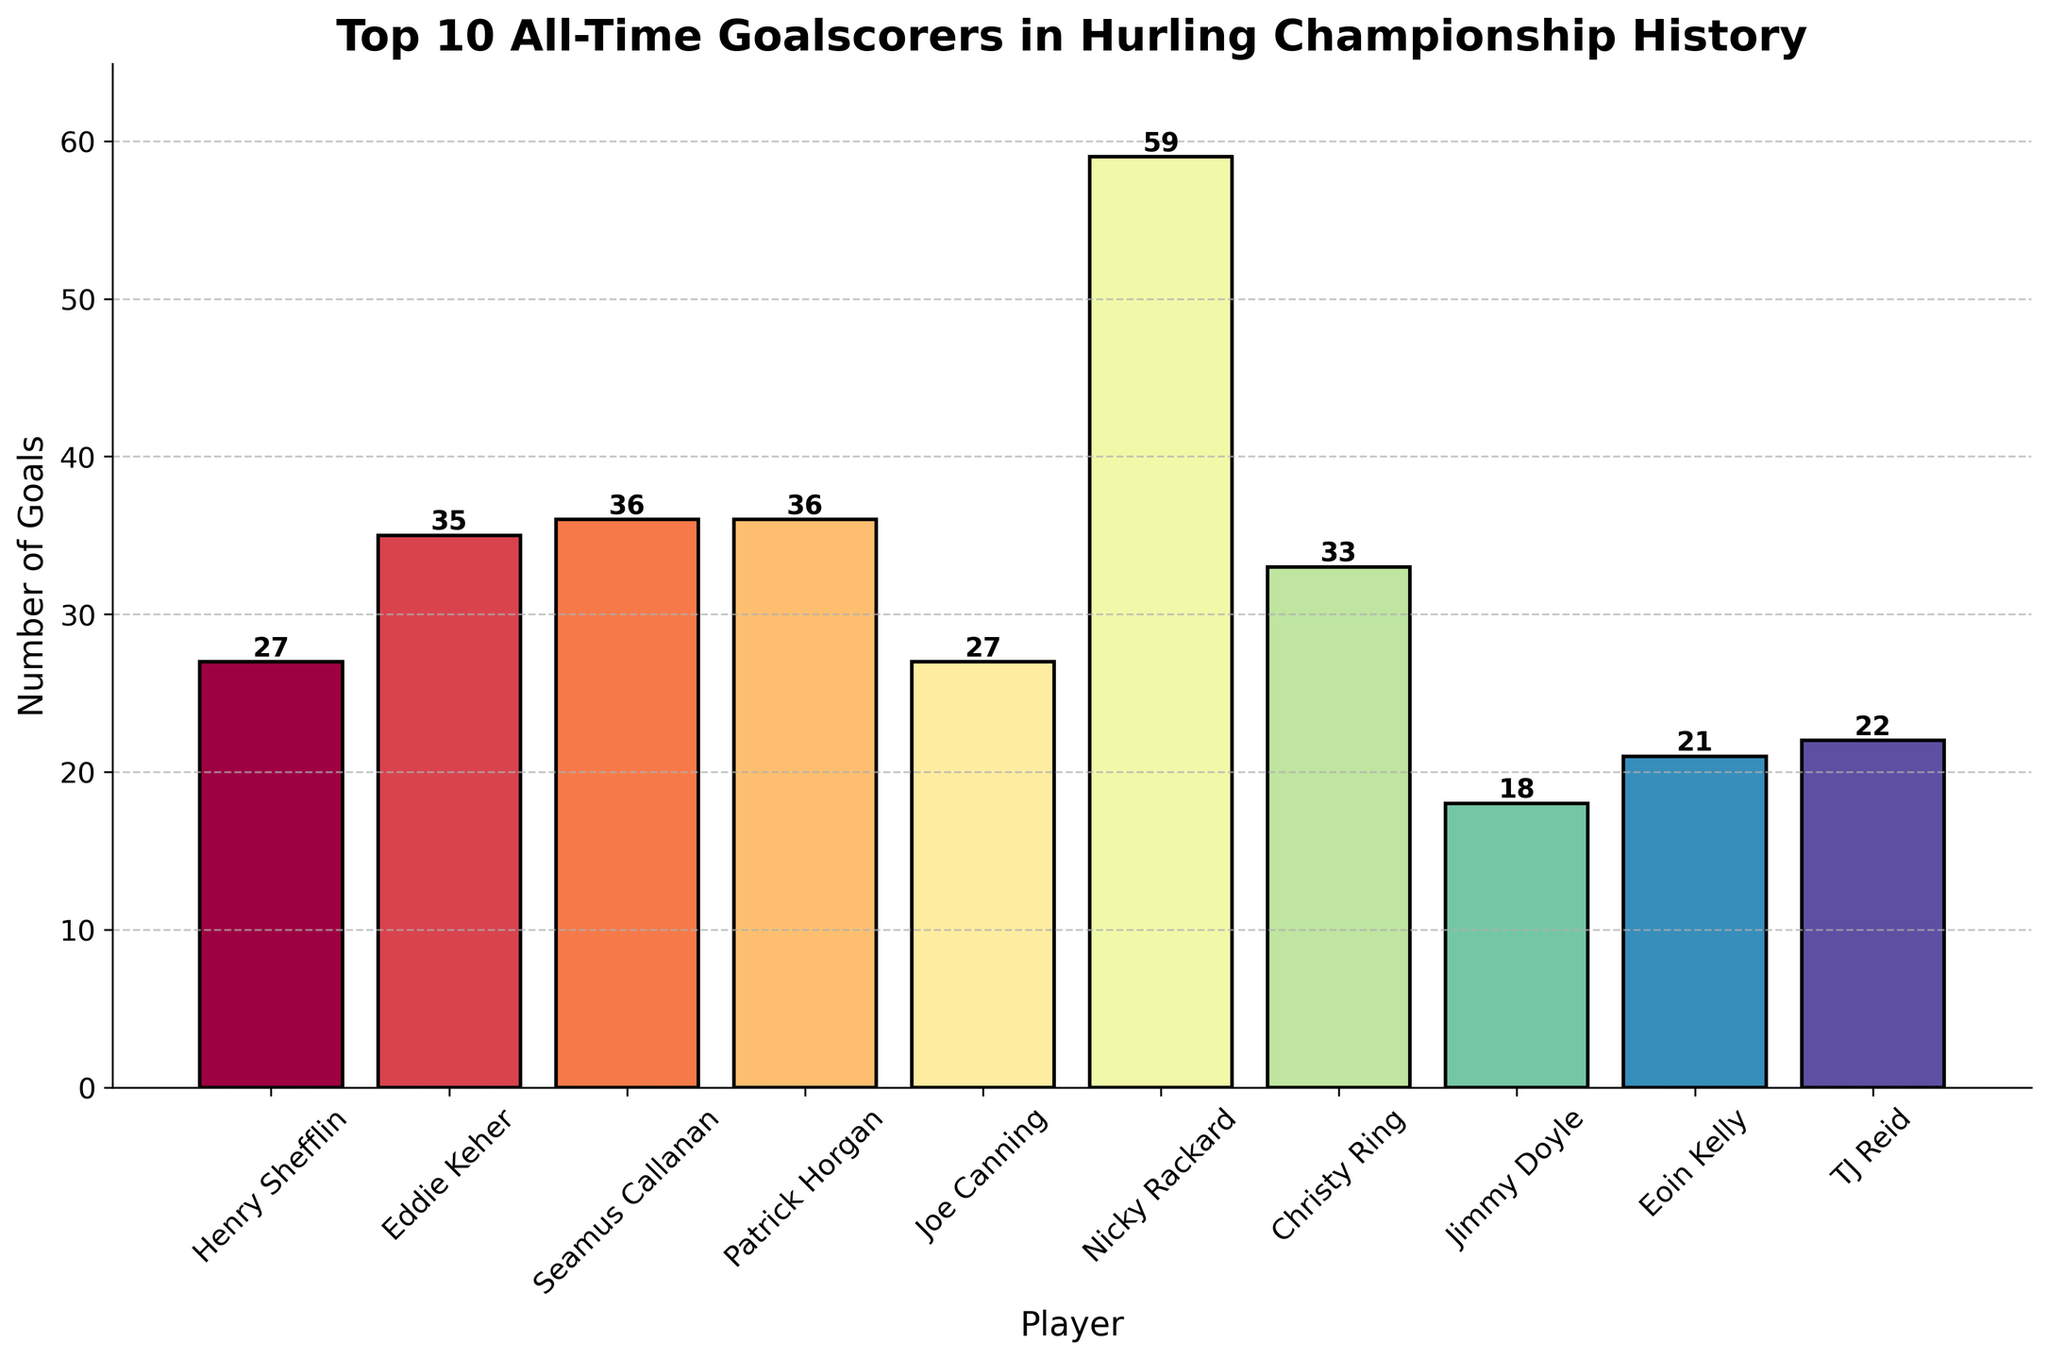Which player scored the most goals? By observing the heights of the bars, the tallest bar represents the player with the most goals. Nicky Rackard has the highest bar.
Answer: Nicky Rackard Who has more goals, Christy Ring or Henry Shefflin? Comparing the heights of the bars of Christy Ring and Henry Shefflin, Christy Ring's bar is taller.
Answer: Christy Ring What is the total number of goals scored by all players combined? Adding the number of goals for all players listed: 27 + 35 + 36 + 36 + 27 + 59 + 33 + 18 + 21 + 22 = 314
Answer: 314 Who scored fewer goals, Jimmy Doyle or Eoin Kelly? Comparing the heights of the bars for Jimmy Doyle and Eoin Kelly, Jimmy Doyle's bar is shorter.
Answer: Jimmy Doyle What is the average number of goals scored by these top 10 players? The total number of goals scored is 314 (from the previous question). To find the average: 314 / 10 = 31.4
Answer: 31.4 Are there any players who have scored the same number of goals? If so, who are they? Observing the bars, Seamus Callanan and Patrick Horgan both have bars with the same height of 36 goals. Similarly, Henry Shefflin and Joe Canning both have bars of 27 goals.
Answer: Seamus Callanan and Patrick Horgan, Henry Shefflin and Joe Canning Which player holds the third-highest goal tally? Arranging the players by the height of their bars in descending order, the third-highest after Nicky Rackard and Patrick Horgan/Seamus Callanan (tie) is Eddie Keher with 35 goals.
Answer: Eddie Keher How many more goals did Nicky Rackard score compared to the player with the least goals? Nicky Rackard scored 59 goals and Jimmy Doyle, the player with the least goals, scored 18 goals. Calculating the difference: 59 - 18 = 41
Answer: 41 What is the median number of goals scored by these players? To find the median, arrange the number of goals in ascending order and find the middle value: 18, 21, 22, 27, 27, 33, 35, 36, 36, 59. The median is the average of the 5th and 6th values: (27 + 33) / 2 = 30
Answer: 30 